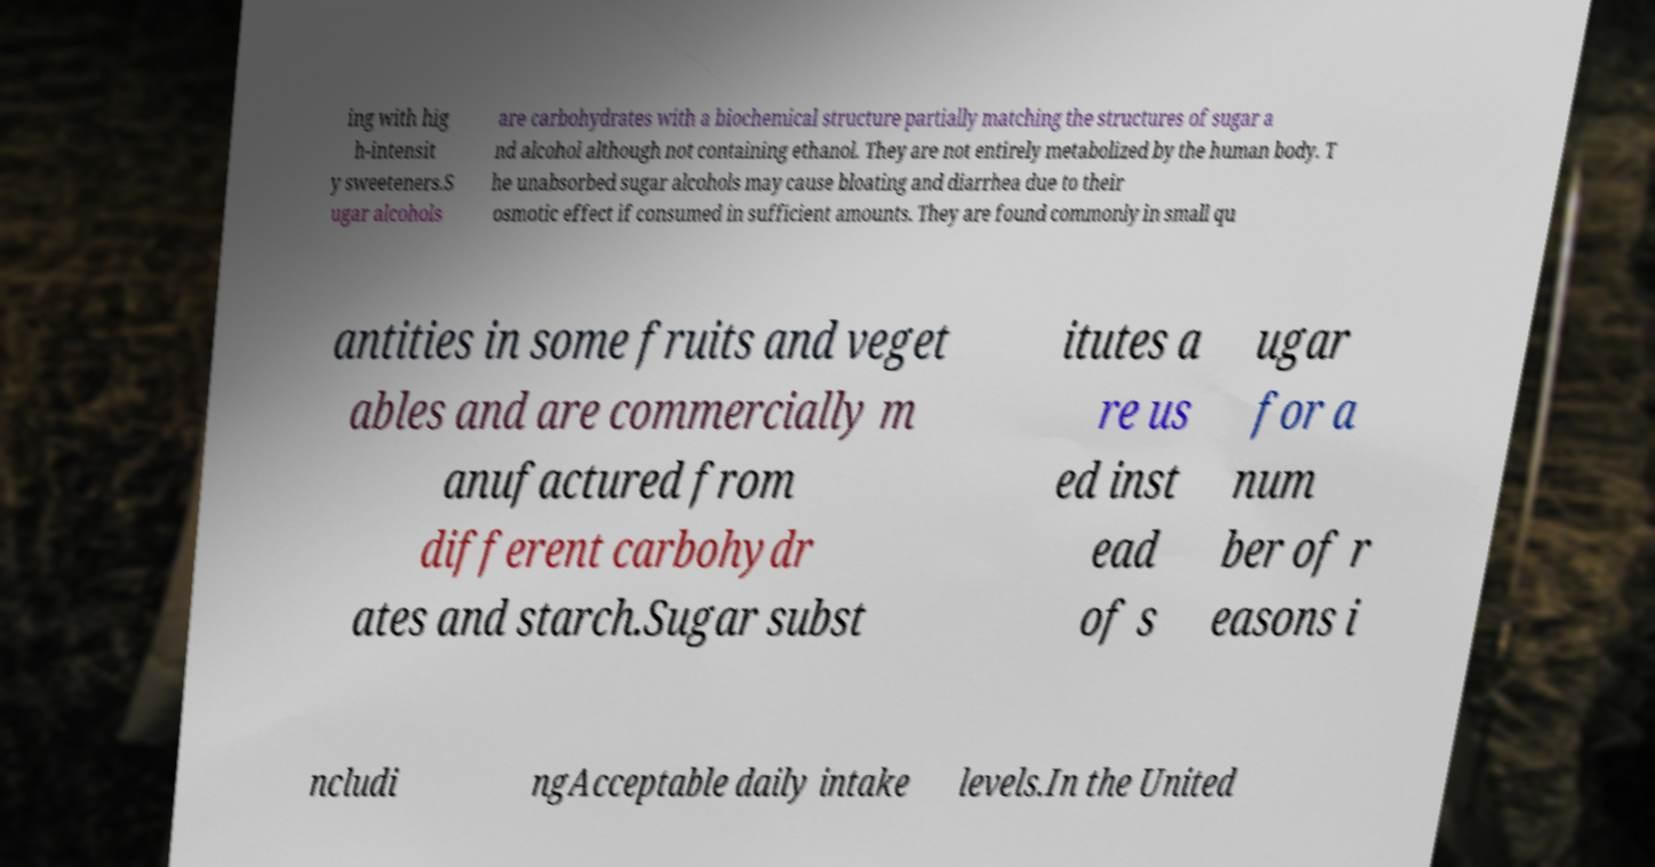For documentation purposes, I need the text within this image transcribed. Could you provide that? ing with hig h-intensit y sweeteners.S ugar alcohols are carbohydrates with a biochemical structure partially matching the structures of sugar a nd alcohol although not containing ethanol. They are not entirely metabolized by the human body. T he unabsorbed sugar alcohols may cause bloating and diarrhea due to their osmotic effect if consumed in sufficient amounts. They are found commonly in small qu antities in some fruits and veget ables and are commercially m anufactured from different carbohydr ates and starch.Sugar subst itutes a re us ed inst ead of s ugar for a num ber of r easons i ncludi ngAcceptable daily intake levels.In the United 